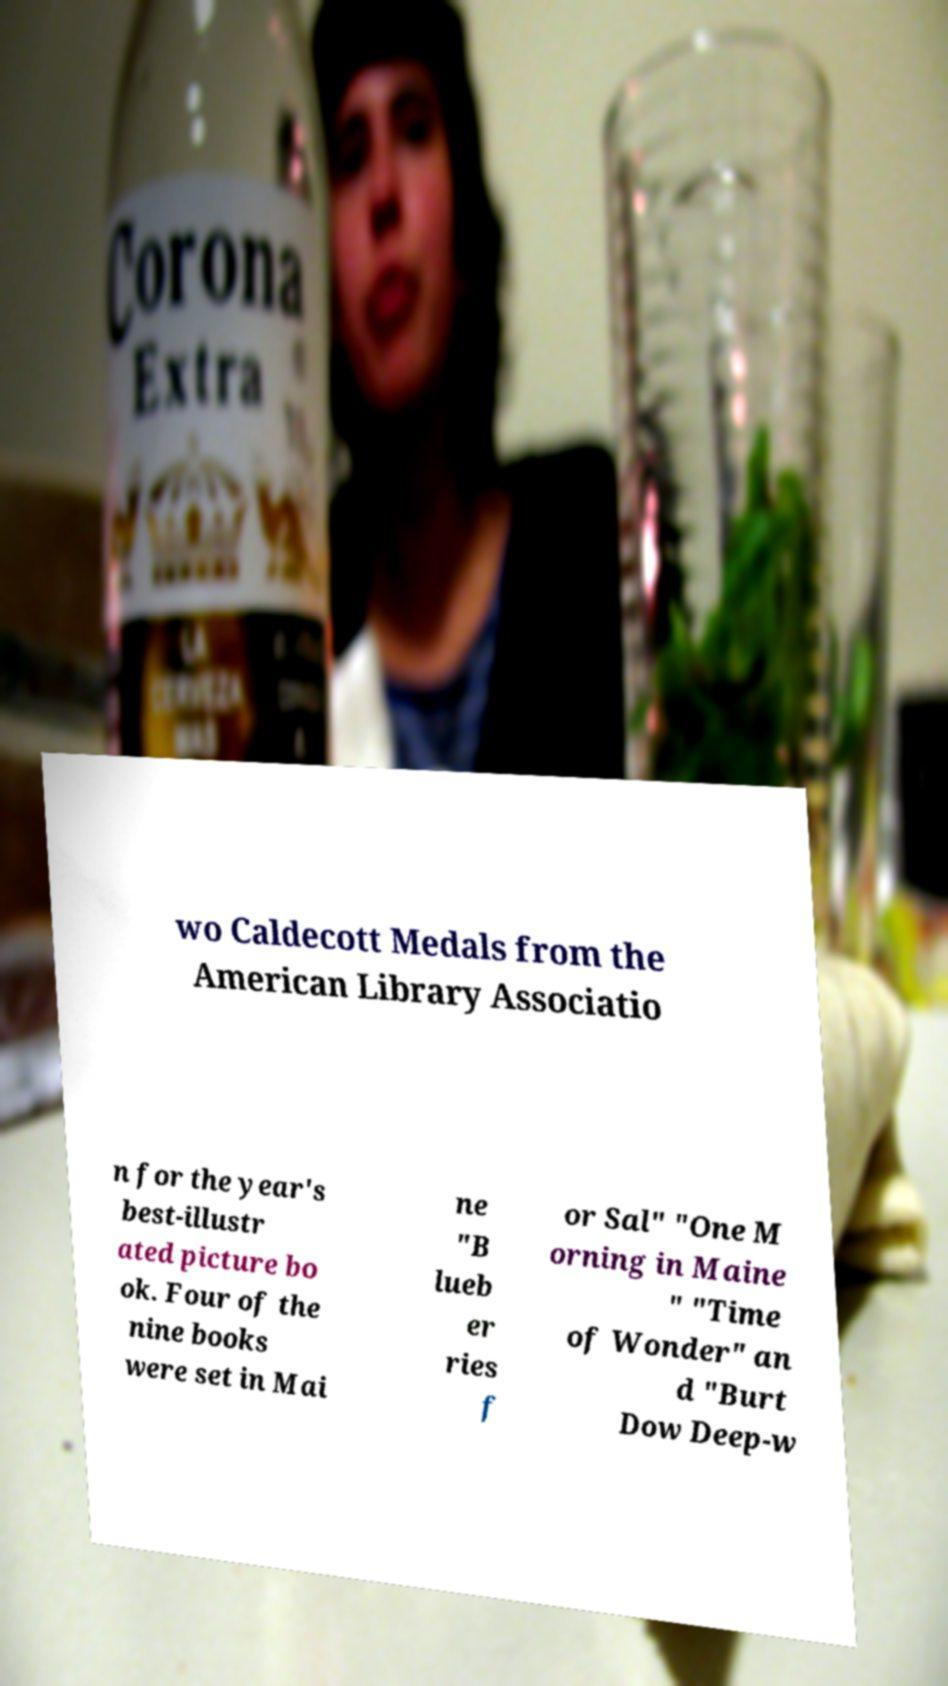Could you assist in decoding the text presented in this image and type it out clearly? wo Caldecott Medals from the American Library Associatio n for the year's best-illustr ated picture bo ok. Four of the nine books were set in Mai ne "B lueb er ries f or Sal" "One M orning in Maine " "Time of Wonder" an d "Burt Dow Deep-w 